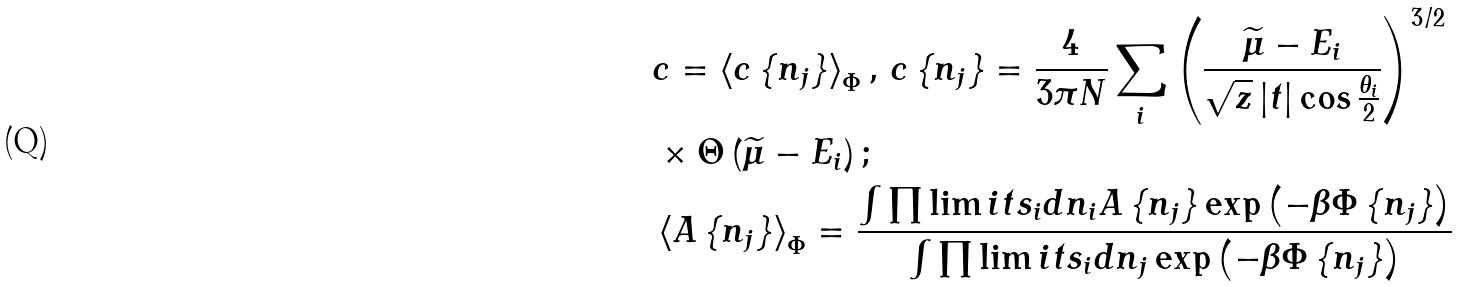<formula> <loc_0><loc_0><loc_500><loc_500>& c = \left \langle c \left \{ n _ { j } \right \} \right \rangle _ { \Phi } , \, c \left \{ n _ { j } \right \} = \frac { 4 } { 3 \pi N } \sum _ { i } \left ( \frac { \widetilde { \mu } - E _ { i } } { \sqrt { z } \left | t \right | \cos \frac { \theta _ { i } } { 2 } } \right ) ^ { 3 / 2 } \\ & \times \Theta \left ( \widetilde { \mu } - E _ { i } \right ) ; \\ & \left \langle A \left \{ n _ { j } \right \} \right \rangle _ { \Phi } = \frac { \int \prod \lim i t s _ { i } d n _ { i } A \left \{ n _ { j } \right \} \exp \left ( - \beta \Phi \left \{ n _ { j } \right \} \right ) } { \int \prod \lim i t s _ { i } d n _ { j } \exp \left ( - \beta \Phi \left \{ n _ { j } \right \} \right ) }</formula> 